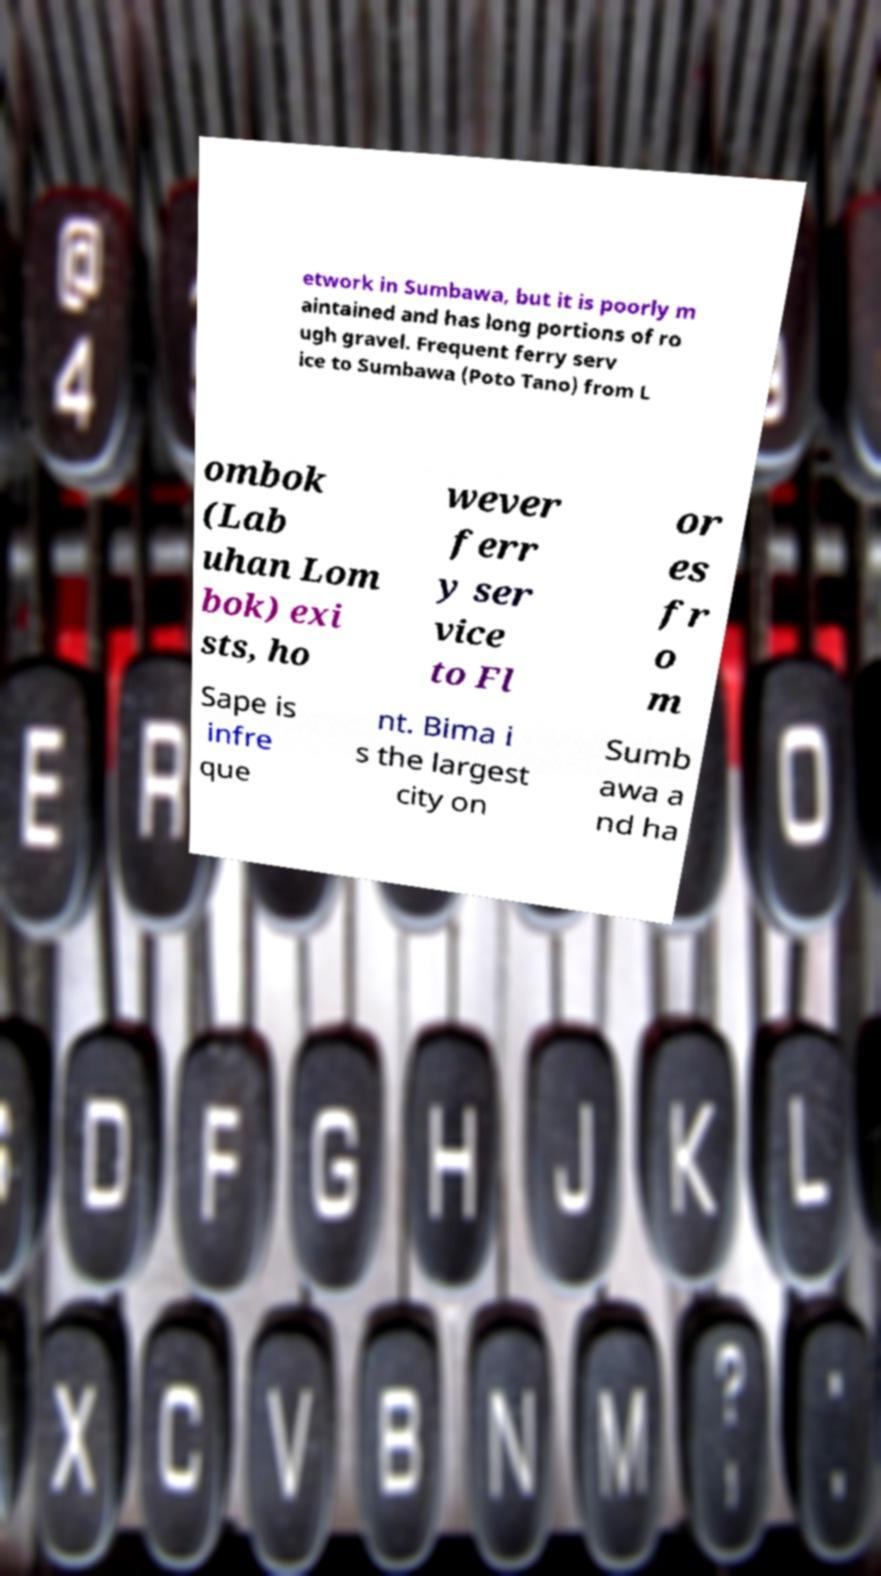What messages or text are displayed in this image? I need them in a readable, typed format. etwork in Sumbawa, but it is poorly m aintained and has long portions of ro ugh gravel. Frequent ferry serv ice to Sumbawa (Poto Tano) from L ombok (Lab uhan Lom bok) exi sts, ho wever ferr y ser vice to Fl or es fr o m Sape is infre que nt. Bima i s the largest city on Sumb awa a nd ha 